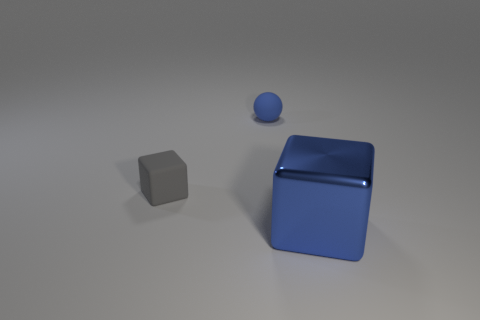Can you describe the shapes and colors present in the image? Certainly! In the image, we observe three distinct shapes: a gray cube, a blue sphere, and a larger blue cube with what seems to be a slightly shinier surface. The colors are fairly muted, consisting of a monochromatic gray background that contrasts with the gray and blue objects, which provides a simplistic yet visually interesting composition. 